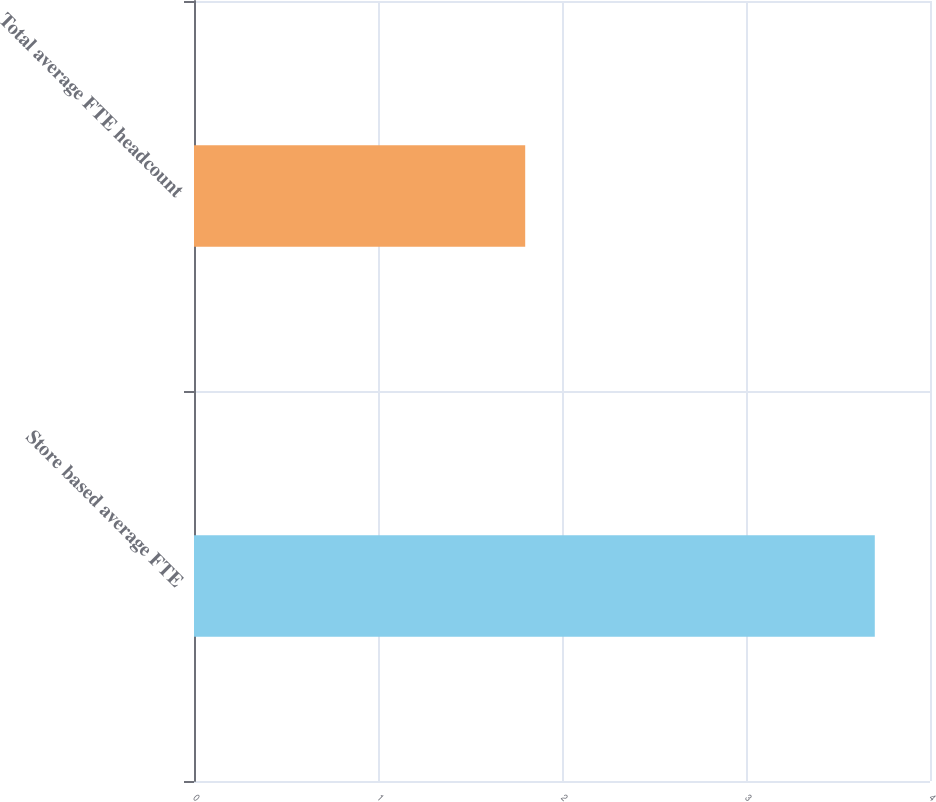<chart> <loc_0><loc_0><loc_500><loc_500><bar_chart><fcel>Store based average FTE<fcel>Total average FTE headcount<nl><fcel>3.7<fcel>1.8<nl></chart> 